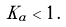Convert formula to latex. <formula><loc_0><loc_0><loc_500><loc_500>K _ { a } < 1 \, .</formula> 